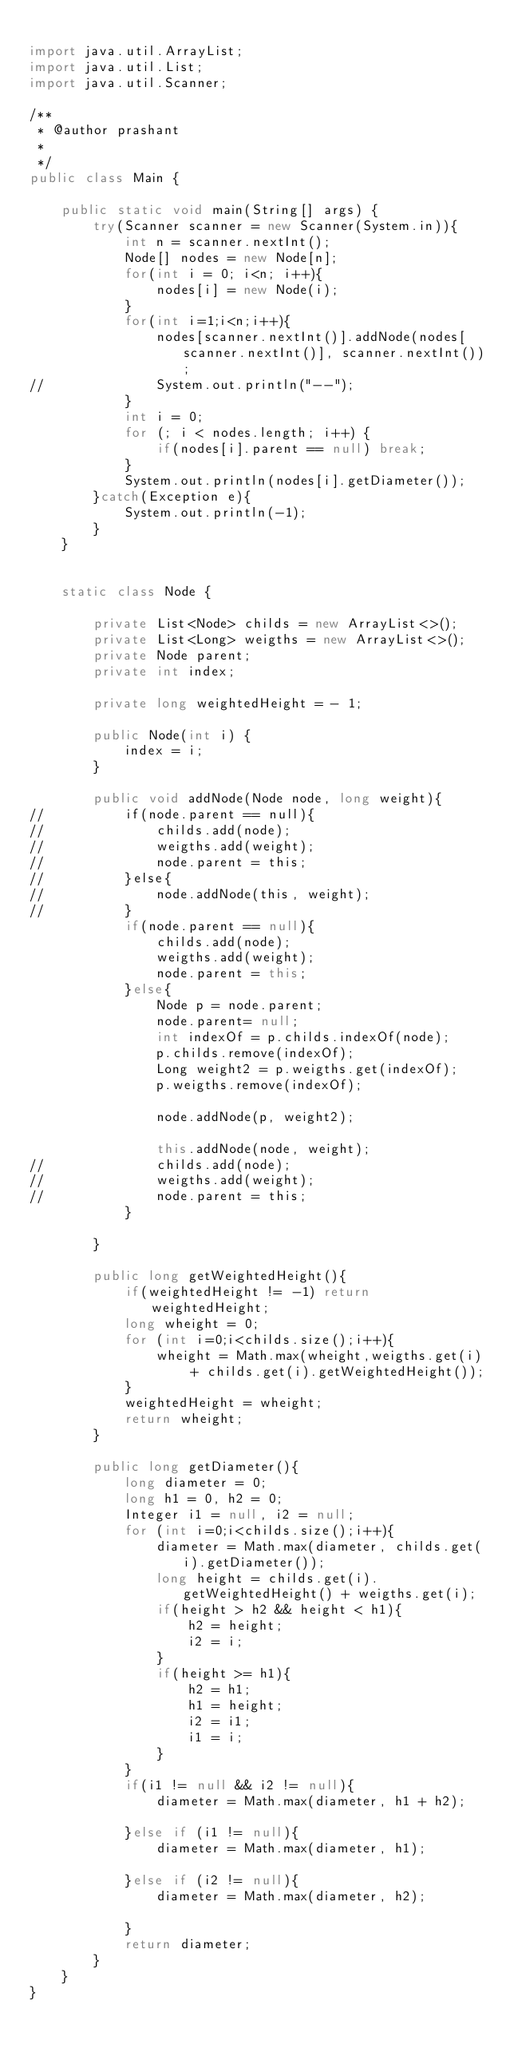<code> <loc_0><loc_0><loc_500><loc_500><_Java_>
import java.util.ArrayList;
import java.util.List;
import java.util.Scanner;

/**
 * @author prashant
 *
 */
public class Main {

	public static void main(String[] args) {
		try(Scanner scanner = new Scanner(System.in)){
			int n = scanner.nextInt();
			Node[] nodes = new Node[n];
			for(int i = 0; i<n; i++){
				nodes[i] = new Node(i);				
			}
			for(int i=1;i<n;i++){
				nodes[scanner.nextInt()].addNode(nodes[scanner.nextInt()], scanner.nextInt());
//				System.out.println("--");
			}
			int i = 0;
			for (; i < nodes.length; i++) {
				if(nodes[i].parent == null) break;
			}
			System.out.println(nodes[i].getDiameter());
		}catch(Exception e){
			System.out.println(-1);
		}
	}
	
	
	static class Node {
		
		private List<Node> childs = new ArrayList<>();
		private List<Long> weigths = new ArrayList<>();
		private Node parent;
		private int index;
		
		private long weightedHeight = - 1;
		
		public Node(int i) {
			index = i;
		}

		public void addNode(Node node, long weight){
//			if(node.parent == null){
//				childs.add(node);
//				weigths.add(weight);
//				node.parent = this;
//			}else{
//				node.addNode(this, weight);
//			}
			if(node.parent == null){
				childs.add(node);
				weigths.add(weight);
				node.parent = this;
			}else{
				Node p = node.parent;
				node.parent= null;
				int indexOf = p.childs.indexOf(node);
				p.childs.remove(indexOf);
				Long weight2 = p.weigths.get(indexOf);
				p.weigths.remove(indexOf);
				
				node.addNode(p, weight2);

				this.addNode(node, weight);
//				childs.add(node);
//				weigths.add(weight);
//				node.parent = this;
			}
		
		}
		
		public long getWeightedHeight(){
			if(weightedHeight != -1) return weightedHeight;
			long wheight = 0;
			for (int i=0;i<childs.size();i++){
				wheight = Math.max(wheight,weigths.get(i) + childs.get(i).getWeightedHeight());
			}
			weightedHeight = wheight;
			return wheight;
		}
		
		public long getDiameter(){
			long diameter = 0;
			long h1 = 0, h2 = 0;
			Integer i1 = null, i2 = null;
			for (int i=0;i<childs.size();i++){
				diameter = Math.max(diameter, childs.get(i).getDiameter());
				long height = childs.get(i).getWeightedHeight() + weigths.get(i);
				if(height > h2 && height < h1){
					h2 = height;
					i2 = i;
				}
				if(height >= h1){
					h2 = h1;
					h1 = height;
					i2 = i1;
					i1 = i;
				}
			}
			if(i1 != null && i2 != null){
				diameter = Math.max(diameter, h1 + h2);				
			}else if (i1 != null){
				diameter = Math.max(diameter, h1);					
			}else if (i2 != null){
				diameter = Math.max(diameter, h2);				
			}
			return diameter;
		}
	}
}

</code> 